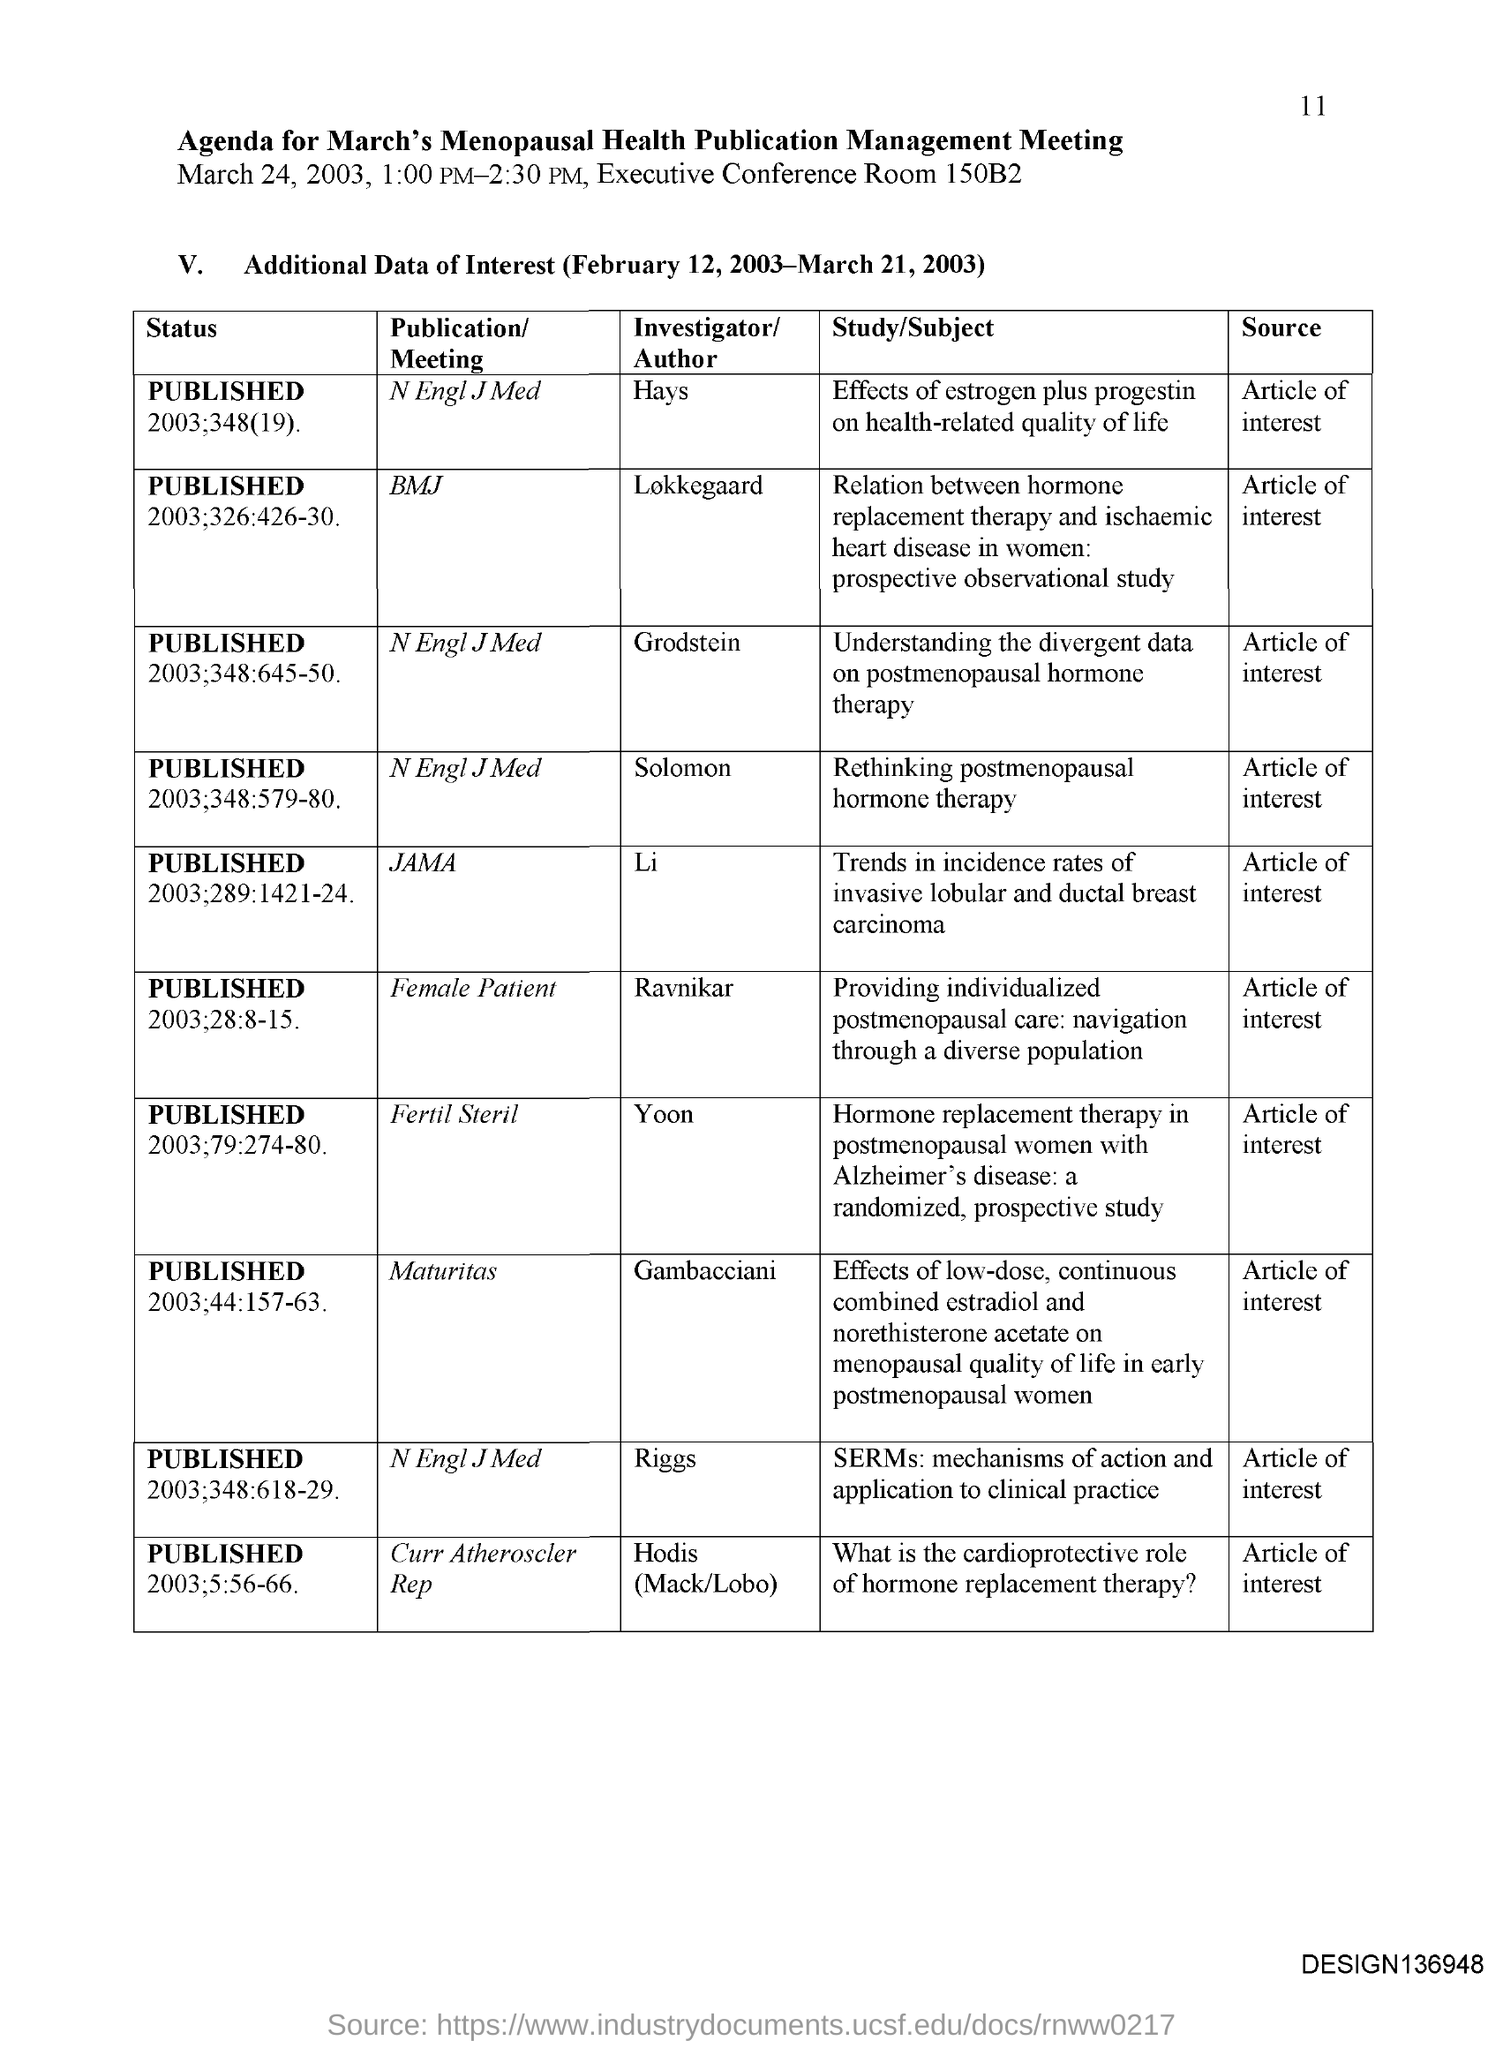Who is the Investigator for the publication BMJ?
Make the answer very short. Lokkegaard. Who is the Investigator for the publication JAMA?
Provide a short and direct response. Li. Who is the Investigator for the publication Fertil Steril?
Give a very brief answer. Yoon. 